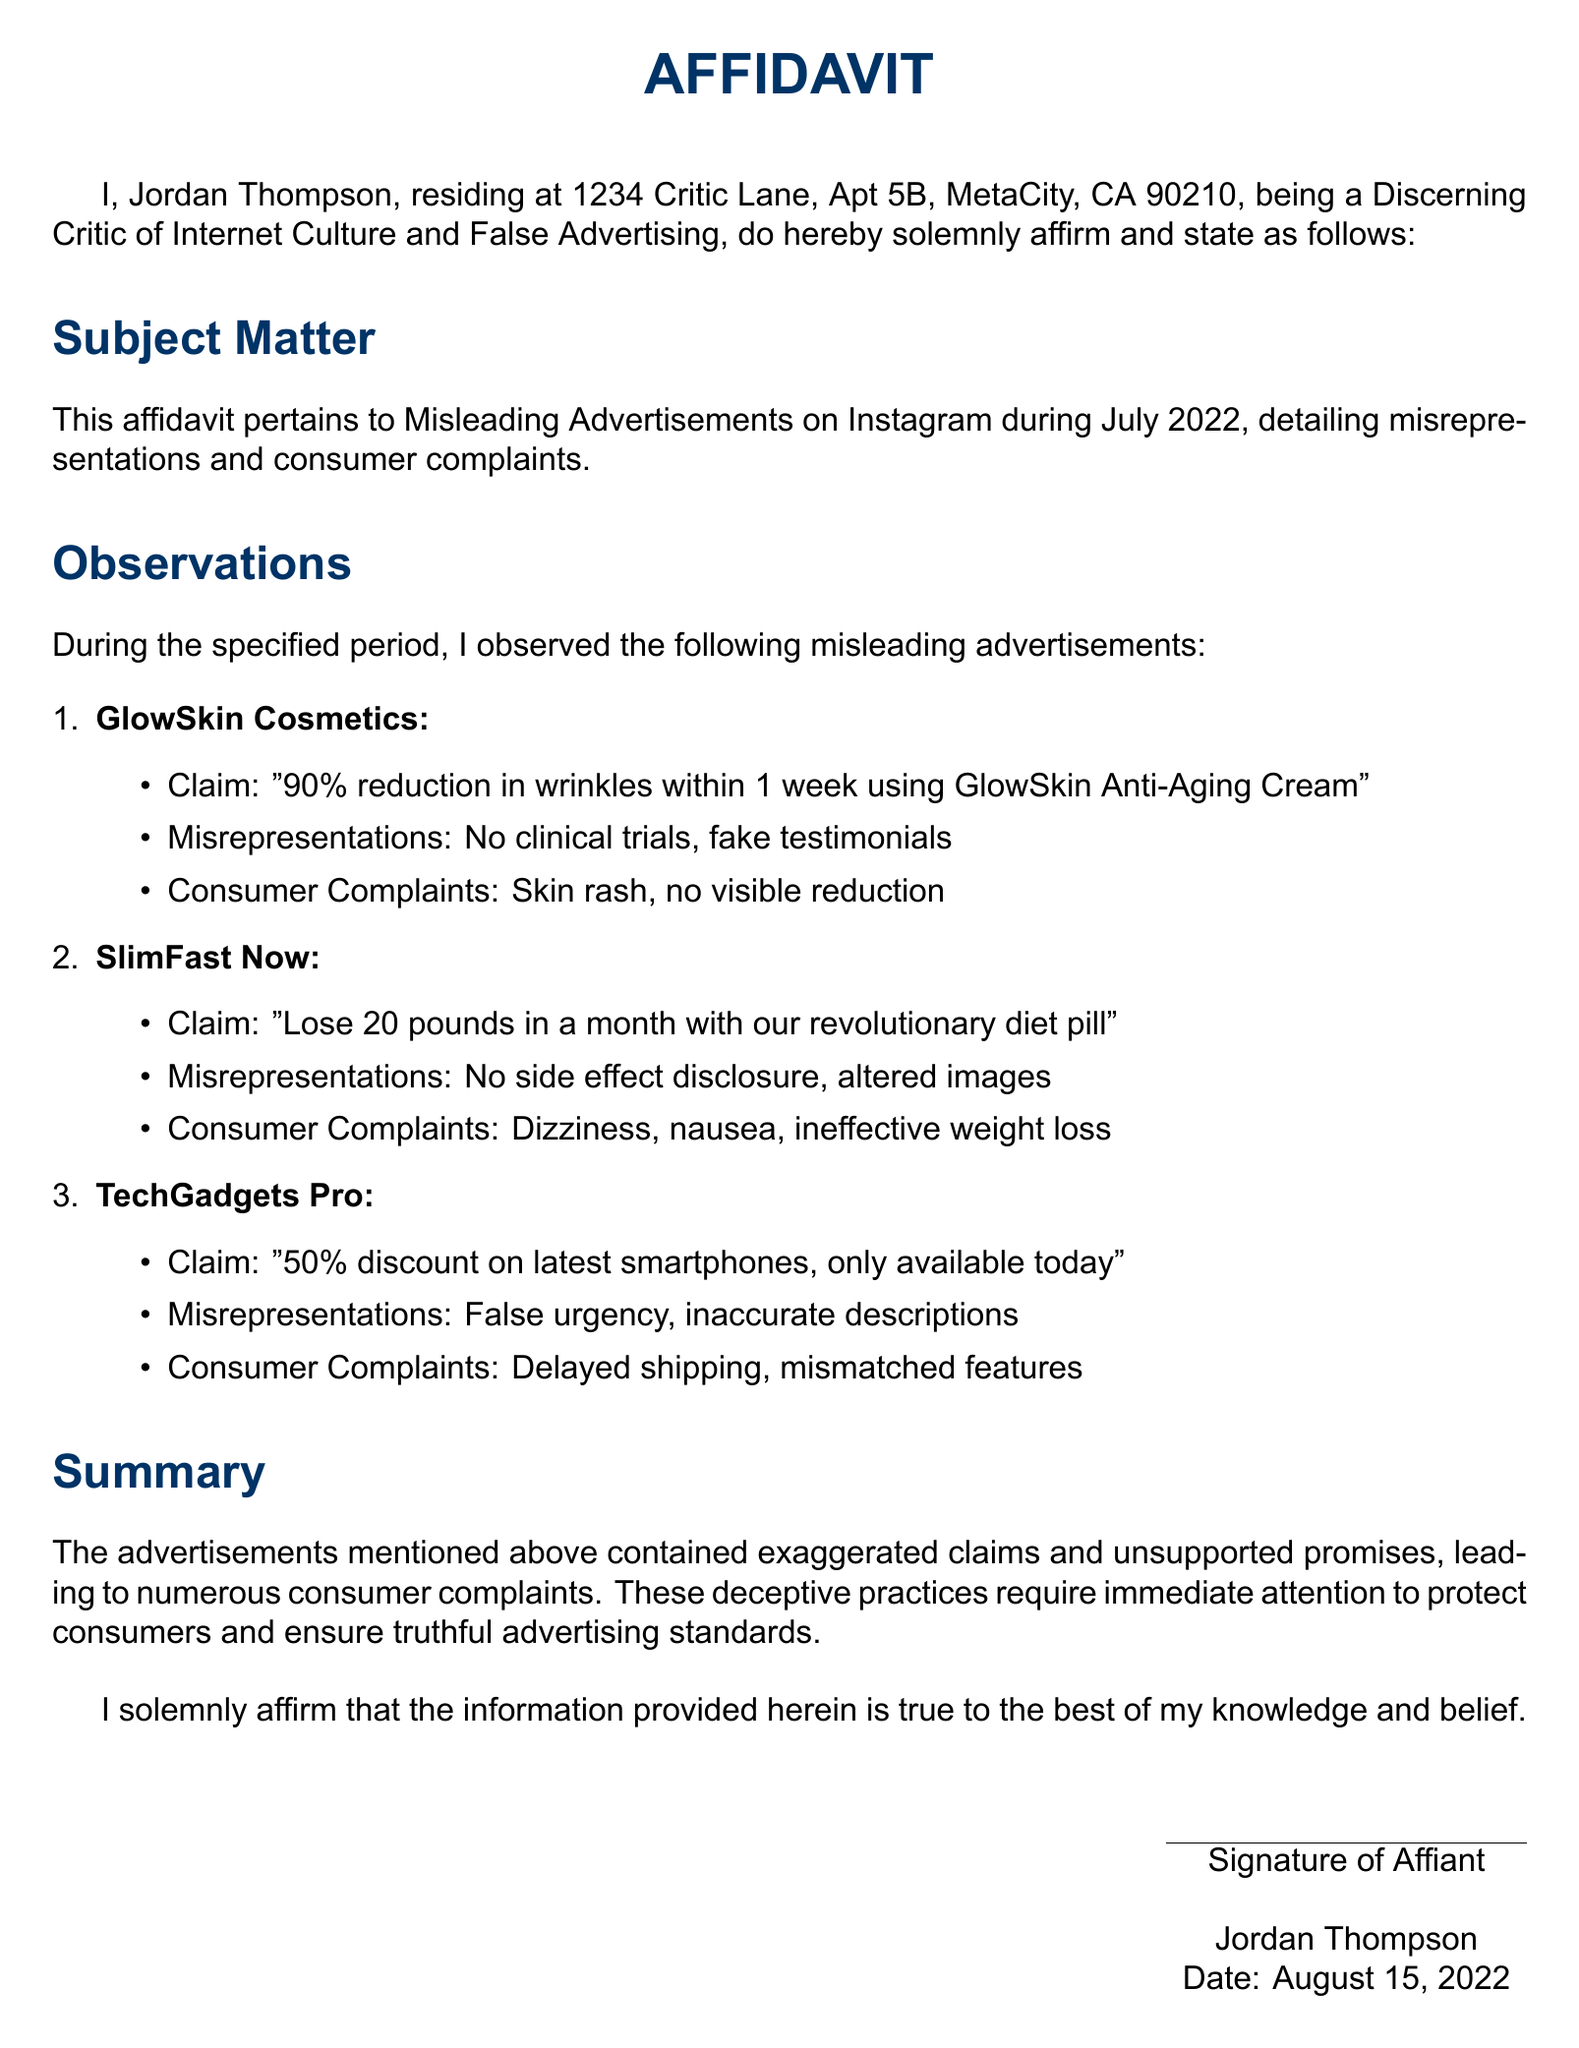What is the name of the affiant? The name of the affiant is stated at the beginning of the document, identifying the individual providing the affidavit.
Answer: Jordan Thompson What is the subject matter of the affidavit? The subject matter outlines the main topic being addressed in the document, specifically misleading advertisements on a social media platform.
Answer: Misleading Advertisements on Instagram during July 2022 How many misleading advertisements are listed in the document? The document provides a detailed list of several misleading advertisements observed during the specified period.
Answer: Three What was the claim made by GlowSkin Cosmetics? The claim is explicitly mentioned under the company's name, revealing the advertised benefit of using their product.
Answer: 90% reduction in wrinkles within 1 week using GlowSkin Anti-Aging Cream What issue did consumers report with SlimFast Now? This question seeks information about specific complaints from consumers regarding the product.
Answer: Dizziness What is stated as the date of the affidavit? This information can be found at the end of the document, indicating when the affidavit was signed.
Answer: August 15, 2022 What kind of evidence was lacking in the advertisements mentioned? The document highlights important missing elements associated with the misleading claims made in the advertisements.
Answer: Clinical trials What does the affidavit recommend regarding deceptive practices? The summary section reveals the affiant's stance on the matter, advocating for a particular action or response.
Answer: Immediate attention What was claimed by TechGadgets Pro regarding smartphone discounts? The claim appears prominently in the description of the company's advertisement for which misleading information was alleged.
Answer: 50% discount on latest smartphones, only available today 